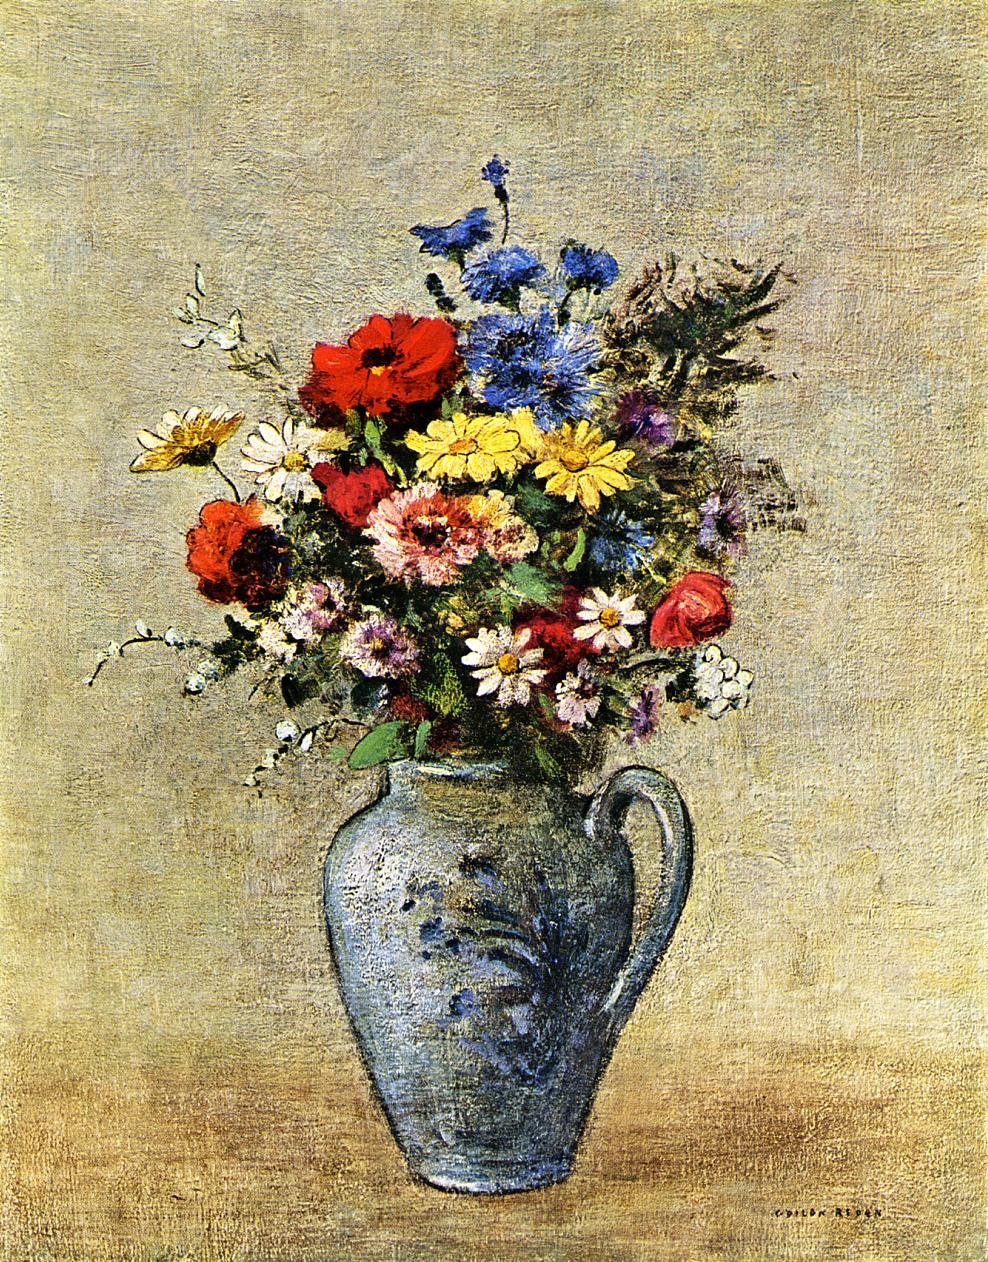Describe the following image. The image presents an impressionist still life painting. The central focus of the painting is a bouquet of flowers, housed in a blue-grey vase with a handle on its left side. The flowers are a vibrant mix of red, yellow, pink, and white, with accents of blue and purple adding depth to the composition. The background is a textured beige color, providing a neutral backdrop that allows the colors of the flowers and vase to stand out. The art style is distinctly impressionist, characterized by loose brushstrokes and a focus on color and light. The genre of the painting is still life, a common theme in impressionist art. The painting captures the transient beauty of the flowers, a hallmark of the impressionist movement. 